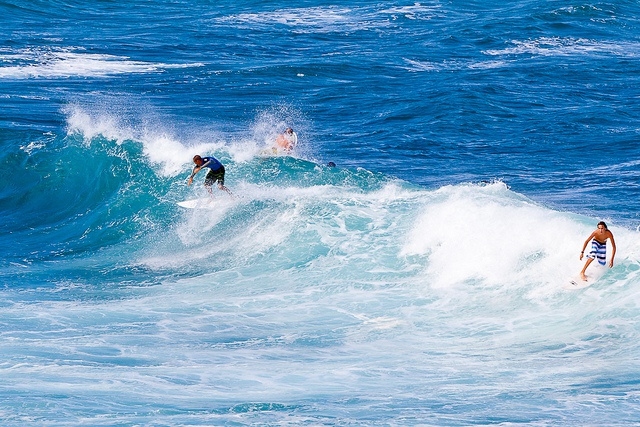Describe the objects in this image and their specific colors. I can see people in teal, black, lightgray, navy, and lightblue tones, people in teal, lavender, brown, and black tones, people in teal, lightgray, lightpink, and darkgray tones, surfboard in teal, lightgray, lightblue, and darkgray tones, and surfboard in teal, white, darkgray, and lightblue tones in this image. 